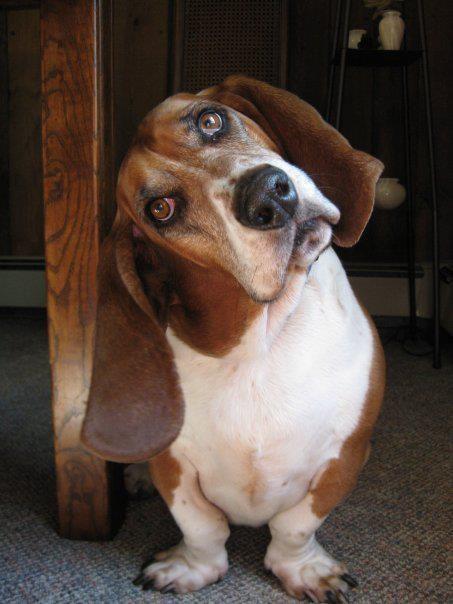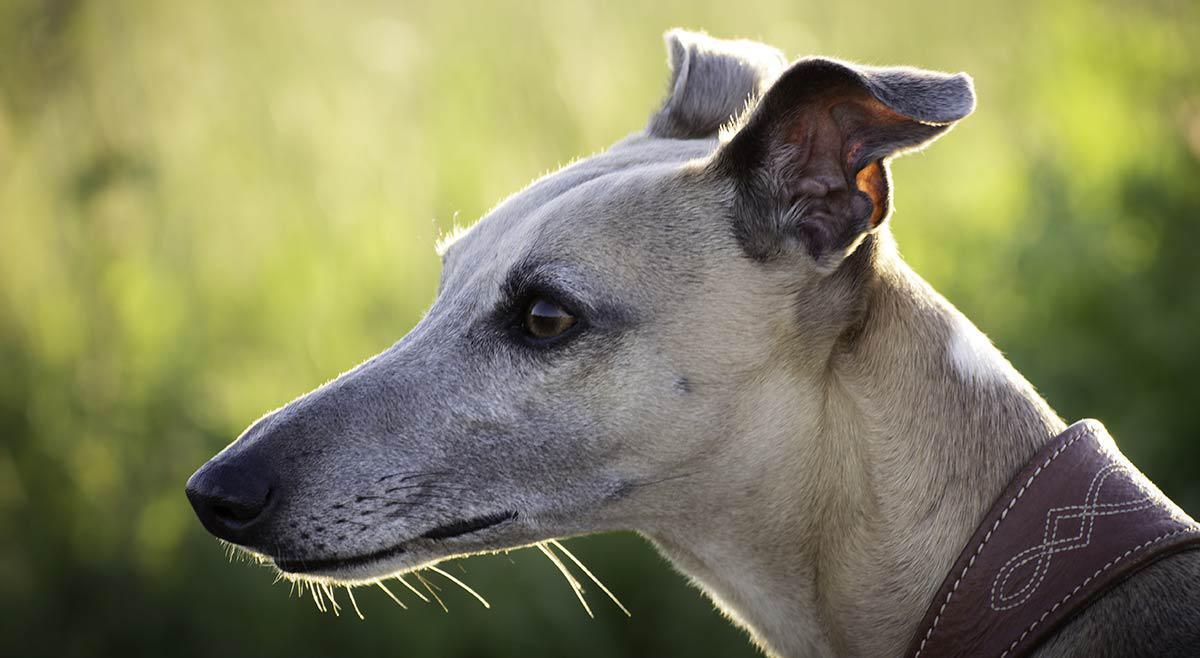The first image is the image on the left, the second image is the image on the right. For the images shown, is this caption "There is a Basset Hound in the image on the left." true? Answer yes or no. Yes. The first image is the image on the left, the second image is the image on the right. Given the left and right images, does the statement "At least one dog has long floppy brown ears, both front paws on the surface in front of it, and a body turned toward the camera." hold true? Answer yes or no. Yes. 